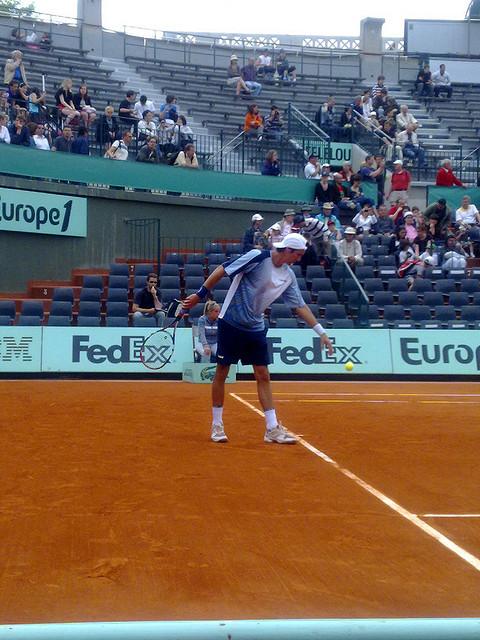What company is sponsoring the match?
Keep it brief. Fedex. What does the advertiser in the background do?
Write a very short answer. Deliver packages. How is the turnout?
Concise answer only. Low. What sport is this?
Answer briefly. Tennis. What sport are they playing?
Be succinct. Tennis. 